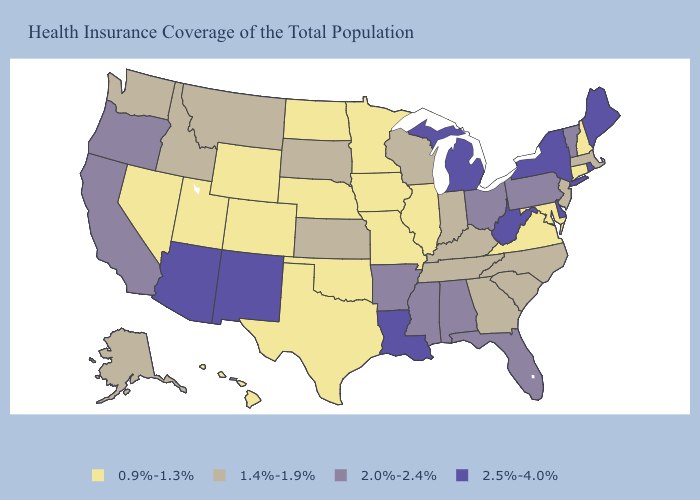Name the states that have a value in the range 2.0%-2.4%?
Answer briefly. Alabama, Arkansas, California, Florida, Mississippi, Ohio, Oregon, Pennsylvania, Vermont. What is the highest value in the USA?
Write a very short answer. 2.5%-4.0%. Among the states that border Michigan , which have the lowest value?
Concise answer only. Indiana, Wisconsin. Among the states that border Utah , which have the lowest value?
Write a very short answer. Colorado, Nevada, Wyoming. What is the lowest value in the MidWest?
Be succinct. 0.9%-1.3%. What is the lowest value in the West?
Give a very brief answer. 0.9%-1.3%. What is the value of Nevada?
Be succinct. 0.9%-1.3%. What is the lowest value in the USA?
Quick response, please. 0.9%-1.3%. Among the states that border Arizona , does New Mexico have the lowest value?
Write a very short answer. No. How many symbols are there in the legend?
Be succinct. 4. What is the highest value in states that border Texas?
Give a very brief answer. 2.5%-4.0%. Which states have the highest value in the USA?
Keep it brief. Arizona, Delaware, Louisiana, Maine, Michigan, New Mexico, New York, Rhode Island, West Virginia. Name the states that have a value in the range 0.9%-1.3%?
Short answer required. Colorado, Connecticut, Hawaii, Illinois, Iowa, Maryland, Minnesota, Missouri, Nebraska, Nevada, New Hampshire, North Dakota, Oklahoma, Texas, Utah, Virginia, Wyoming. Among the states that border Louisiana , does Texas have the highest value?
Quick response, please. No. What is the value of Michigan?
Quick response, please. 2.5%-4.0%. 